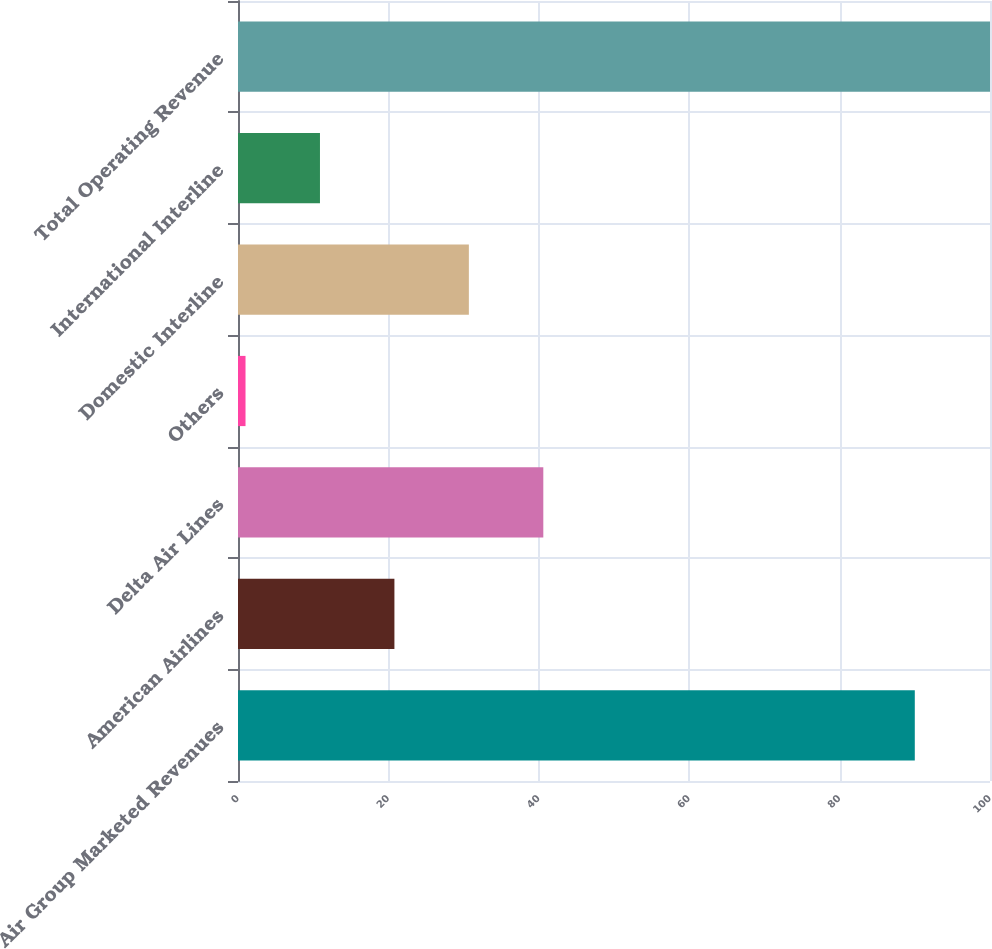<chart> <loc_0><loc_0><loc_500><loc_500><bar_chart><fcel>Air Group Marketed Revenues<fcel>American Airlines<fcel>Delta Air Lines<fcel>Others<fcel>Domestic Interline<fcel>International Interline<fcel>Total Operating Revenue<nl><fcel>90<fcel>20.8<fcel>40.6<fcel>1<fcel>30.7<fcel>10.9<fcel>100<nl></chart> 